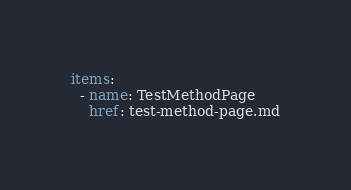Convert code to text. <code><loc_0><loc_0><loc_500><loc_500><_YAML_>items:
  - name: TestMethodPage
    href: test-method-page.md
</code> 